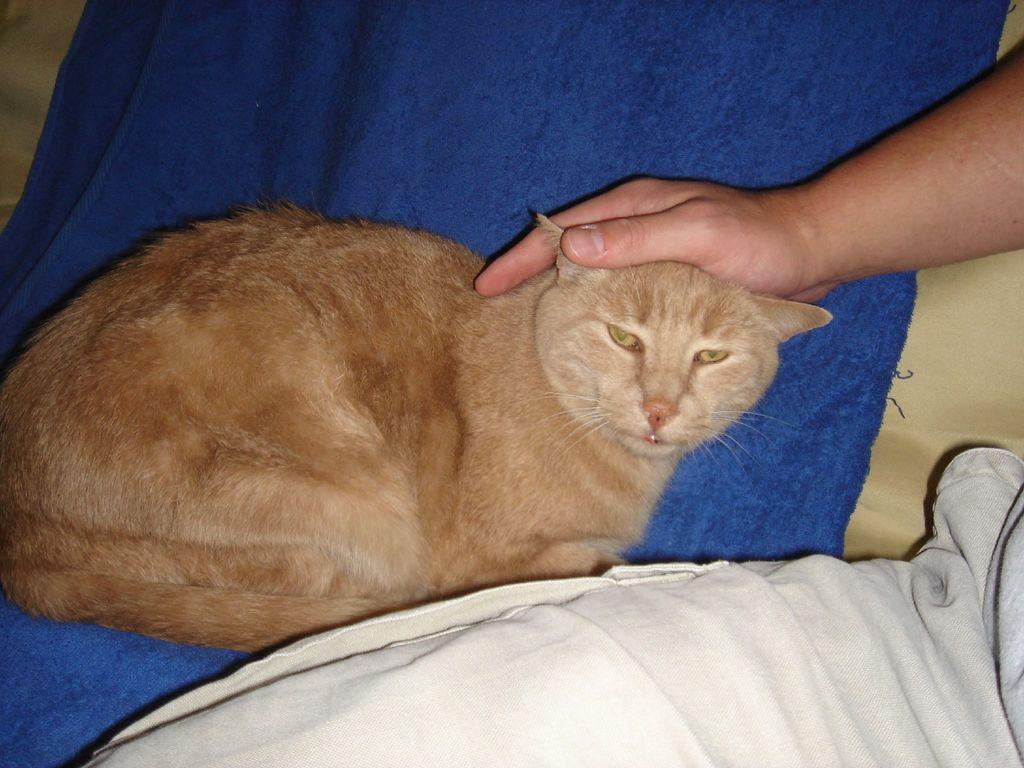What type of animal is in the image? There is a cat in the image. What is the cat sitting on? The cat is on a blue cloth. Can you see any part of a person in the image? Yes, a person's hand is visible in the image. What else is made of cloth in the image? There is cloth in the image. What language does the cat speak in the image? Cats do not speak human languages, so there is no language spoken by the cat in the image. 